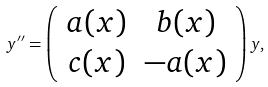<formula> <loc_0><loc_0><loc_500><loc_500>y ^ { \prime \prime } = \left ( \begin{array} { c c } a ( x ) & b ( x ) \\ c ( x ) & - a ( x ) \end{array} \right ) y ,</formula> 